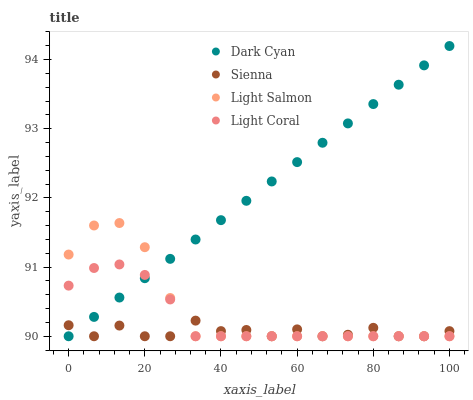Does Sienna have the minimum area under the curve?
Answer yes or no. Yes. Does Dark Cyan have the maximum area under the curve?
Answer yes or no. Yes. Does Light Salmon have the minimum area under the curve?
Answer yes or no. No. Does Light Salmon have the maximum area under the curve?
Answer yes or no. No. Is Dark Cyan the smoothest?
Answer yes or no. Yes. Is Sienna the roughest?
Answer yes or no. Yes. Is Light Salmon the smoothest?
Answer yes or no. No. Is Light Salmon the roughest?
Answer yes or no. No. Does Dark Cyan have the lowest value?
Answer yes or no. Yes. Does Dark Cyan have the highest value?
Answer yes or no. Yes. Does Light Salmon have the highest value?
Answer yes or no. No. Does Light Coral intersect Dark Cyan?
Answer yes or no. Yes. Is Light Coral less than Dark Cyan?
Answer yes or no. No. Is Light Coral greater than Dark Cyan?
Answer yes or no. No. 